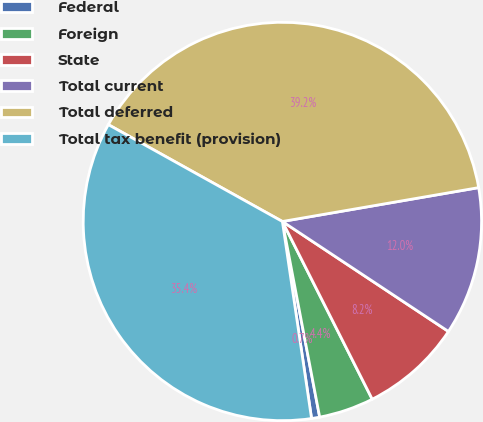<chart> <loc_0><loc_0><loc_500><loc_500><pie_chart><fcel>Federal<fcel>Foreign<fcel>State<fcel>Total current<fcel>Total deferred<fcel>Total tax benefit (provision)<nl><fcel>0.66%<fcel>4.45%<fcel>8.24%<fcel>12.03%<fcel>39.2%<fcel>35.42%<nl></chart> 